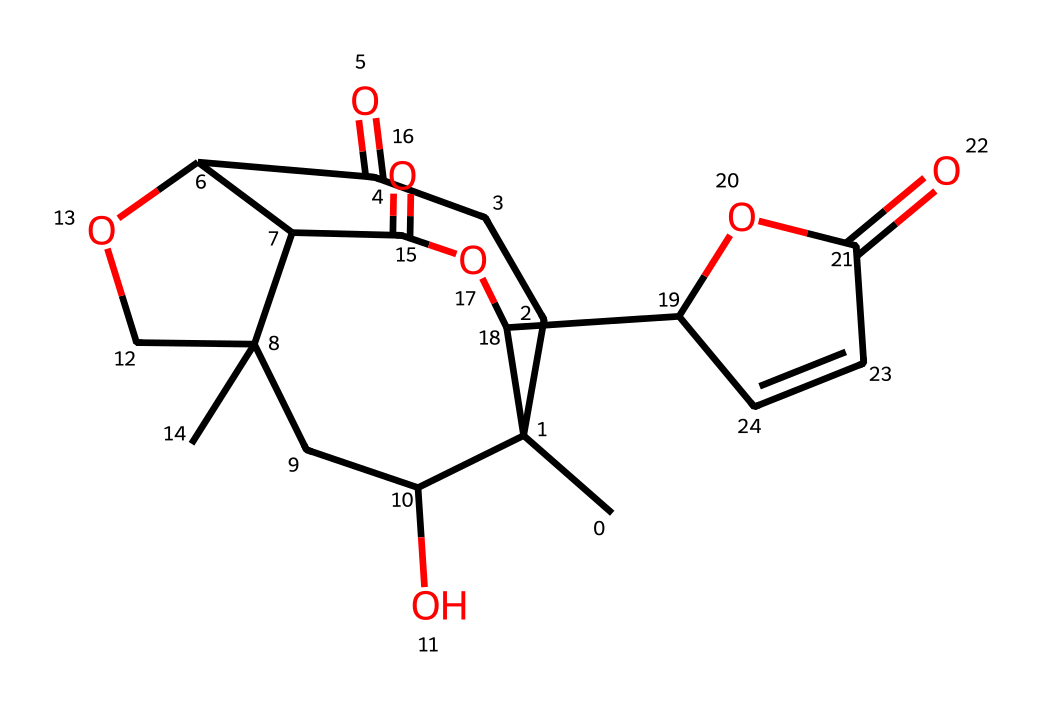How many carbon atoms are present in salvinorin A? By analyzing the SMILES representation, we can count the 'C' symbols, which represent carbon atoms. The SMILES indicates a total of 15 carbon atoms.
Answer: 15 What is the molecular weight of salvinorin A? To find the molecular weight, one needs to sum the weights of all the atoms in the structure. Given the SMILES, the molecular formula is determined to be C15H20O5, leading to a molecular weight of approximately 284.33 g/mol.
Answer: 284.33 How many rings are present in the structure of salvinorin A? The presence of numbers in the SMILES indicates ring closures. By observing these numbers, we find that salvinorin A has 3 interconnected rings in its structure.
Answer: 3 Does salvinorin A contain any nitrogen atoms? Looking at the SMILES representation, there are no 'N' symbols present, indicating that salvinorin A does not contain any nitrogen atoms.
Answer: No What functional groups are found in salvinorin A? By examining the structure, we can identify functional groups such as ketones (C=O), alcohols (C-OH), and esters (C-O-C). These functional groups are prevalent in the structure.
Answer: ketones, alcohols, and esters What stereochemical features can be identified in salvinorin A? A detailed examination of the SMILES shows multiple chiral centers in the structure, as indicated by the presence of carbon atoms bonded to four different substituents, which leads to stereoisomerism.
Answer: chiral centers What type of compound is salvinorin A classified as? Salvinorin A is a naturally occurring diterpene which can be classified as a psychoactive compound due to its interaction with the brain's receptors.
Answer: diterpene 